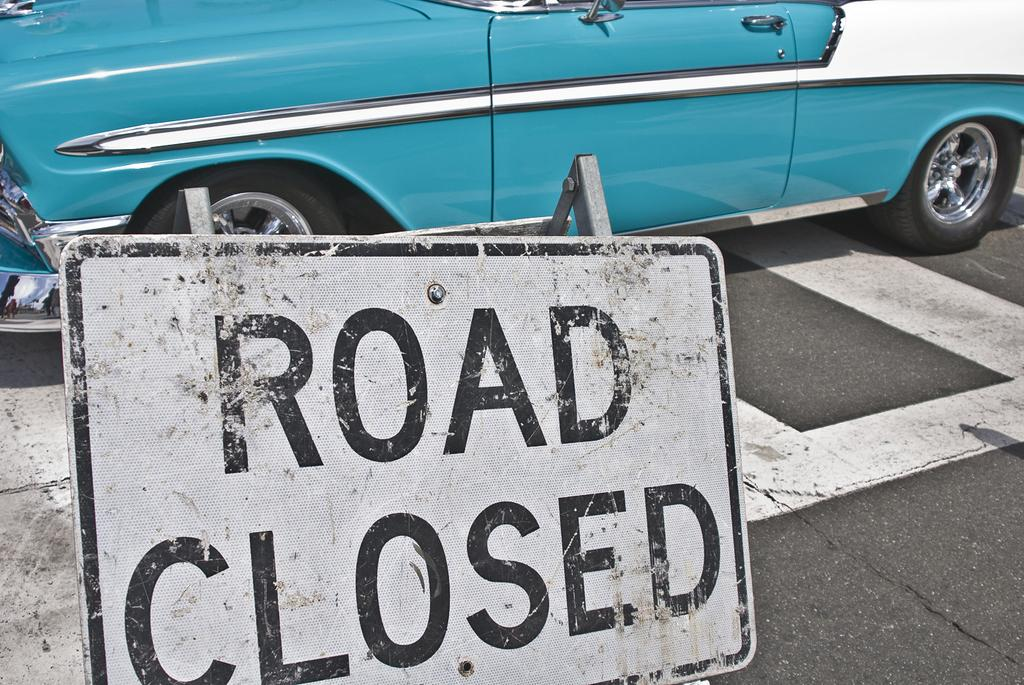What is the main subject of the image? There is a vehicle on the road in the image. What can be seen on the road besides the vehicle? There are white lines on the road. Can you describe anything visible on the right side of the image? There is a reflection visible on the right side of the image. How many snakes are sleeping on the coach in the image? There are no snakes or coaches present in the image. 